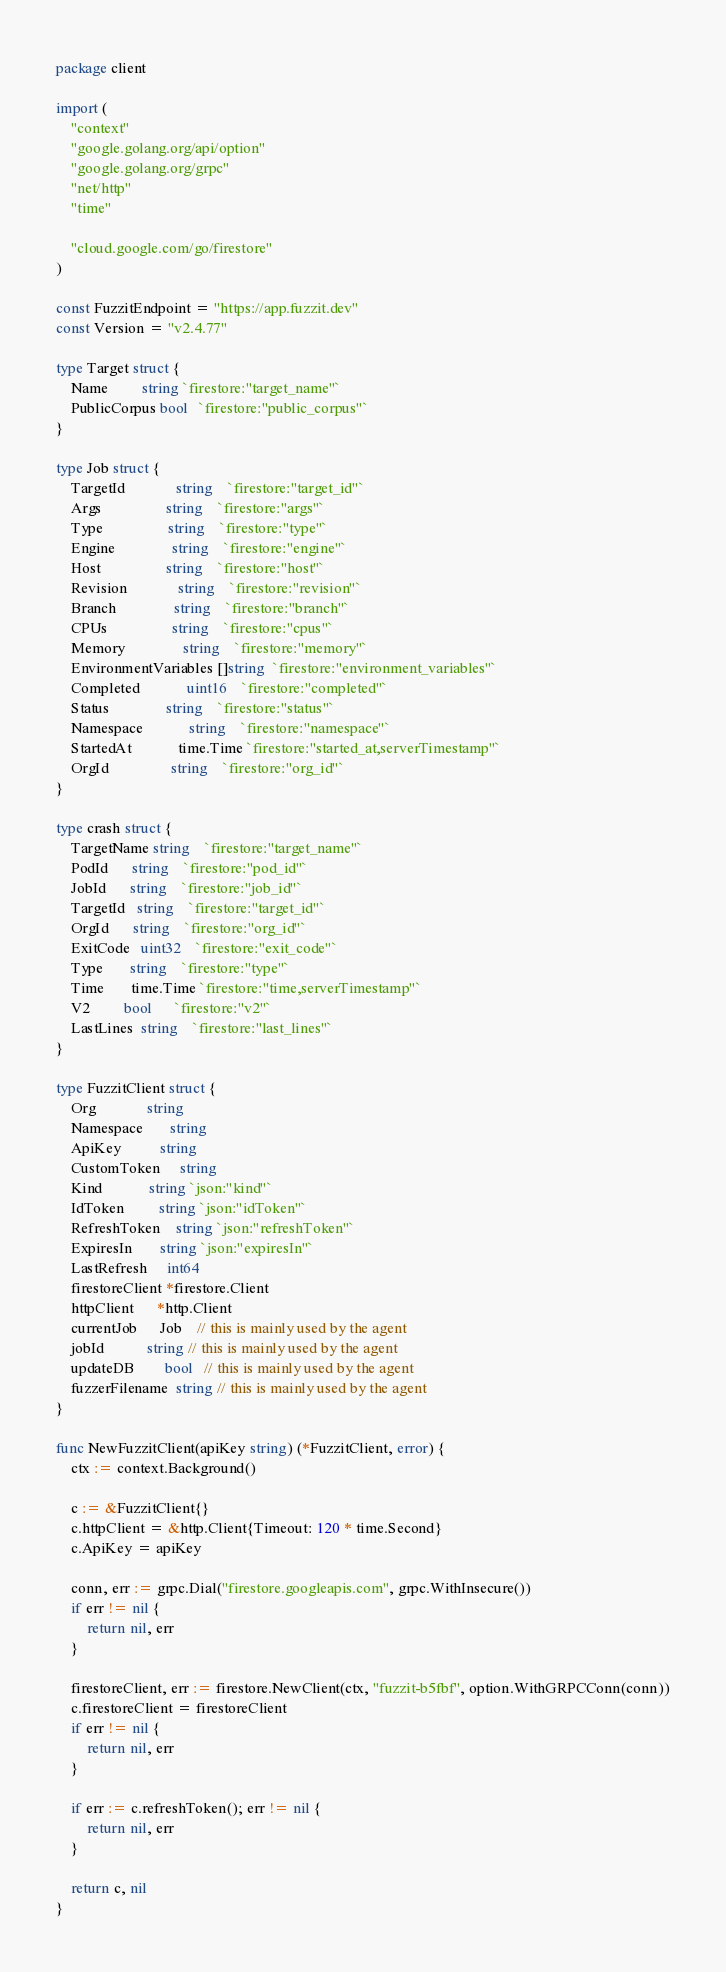<code> <loc_0><loc_0><loc_500><loc_500><_Go_>package client

import (
	"context"
	"google.golang.org/api/option"
	"google.golang.org/grpc"
	"net/http"
	"time"

	"cloud.google.com/go/firestore"
)

const FuzzitEndpoint = "https://app.fuzzit.dev"
const Version = "v2.4.77"

type Target struct {
	Name         string `firestore:"target_name"`
	PublicCorpus bool   `firestore:"public_corpus"`
}

type Job struct {
	TargetId             string    `firestore:"target_id"`
	Args                 string    `firestore:"args"`
	Type                 string    `firestore:"type"`
	Engine               string    `firestore:"engine"`
	Host                 string    `firestore:"host"`
	Revision             string    `firestore:"revision"`
	Branch               string    `firestore:"branch"`
	CPUs                 string    `firestore:"cpus"`
	Memory               string    `firestore:"memory"`
	EnvironmentVariables []string  `firestore:"environment_variables"`
	Completed            uint16    `firestore:"completed"`
	Status               string    `firestore:"status"`
	Namespace            string    `firestore:"namespace"`
	StartedAt            time.Time `firestore:"started_at,serverTimestamp"`
	OrgId                string    `firestore:"org_id"`
}

type crash struct {
	TargetName string    `firestore:"target_name"`
	PodId      string    `firestore:"pod_id"`
	JobId      string    `firestore:"job_id"`
	TargetId   string    `firestore:"target_id"`
	OrgId      string    `firestore:"org_id"`
	ExitCode   uint32    `firestore:"exit_code"`
	Type       string    `firestore:"type"`
	Time       time.Time `firestore:"time,serverTimestamp"`
	V2         bool      `firestore:"v2"`
	LastLines  string    `firestore:"last_lines"`
}

type FuzzitClient struct {
	Org             string
	Namespace       string
	ApiKey          string
	CustomToken     string
	Kind            string `json:"kind"`
	IdToken         string `json:"idToken"`
	RefreshToken    string `json:"refreshToken"`
	ExpiresIn       string `json:"expiresIn"`
	LastRefresh     int64
	firestoreClient *firestore.Client
	httpClient      *http.Client
	currentJob      Job    // this is mainly used by the agent
	jobId           string // this is mainly used by the agent
	updateDB        bool   // this is mainly used by the agent
	fuzzerFilename  string // this is mainly used by the agent
}

func NewFuzzitClient(apiKey string) (*FuzzitClient, error) {
	ctx := context.Background()

	c := &FuzzitClient{}
	c.httpClient = &http.Client{Timeout: 120 * time.Second}
	c.ApiKey = apiKey

	conn, err := grpc.Dial("firestore.googleapis.com", grpc.WithInsecure())
	if err != nil {
		return nil, err
	}

	firestoreClient, err := firestore.NewClient(ctx, "fuzzit-b5fbf", option.WithGRPCConn(conn))
	c.firestoreClient = firestoreClient
	if err != nil {
		return nil, err
	}

	if err := c.refreshToken(); err != nil {
		return nil, err
	}

	return c, nil
}
</code> 